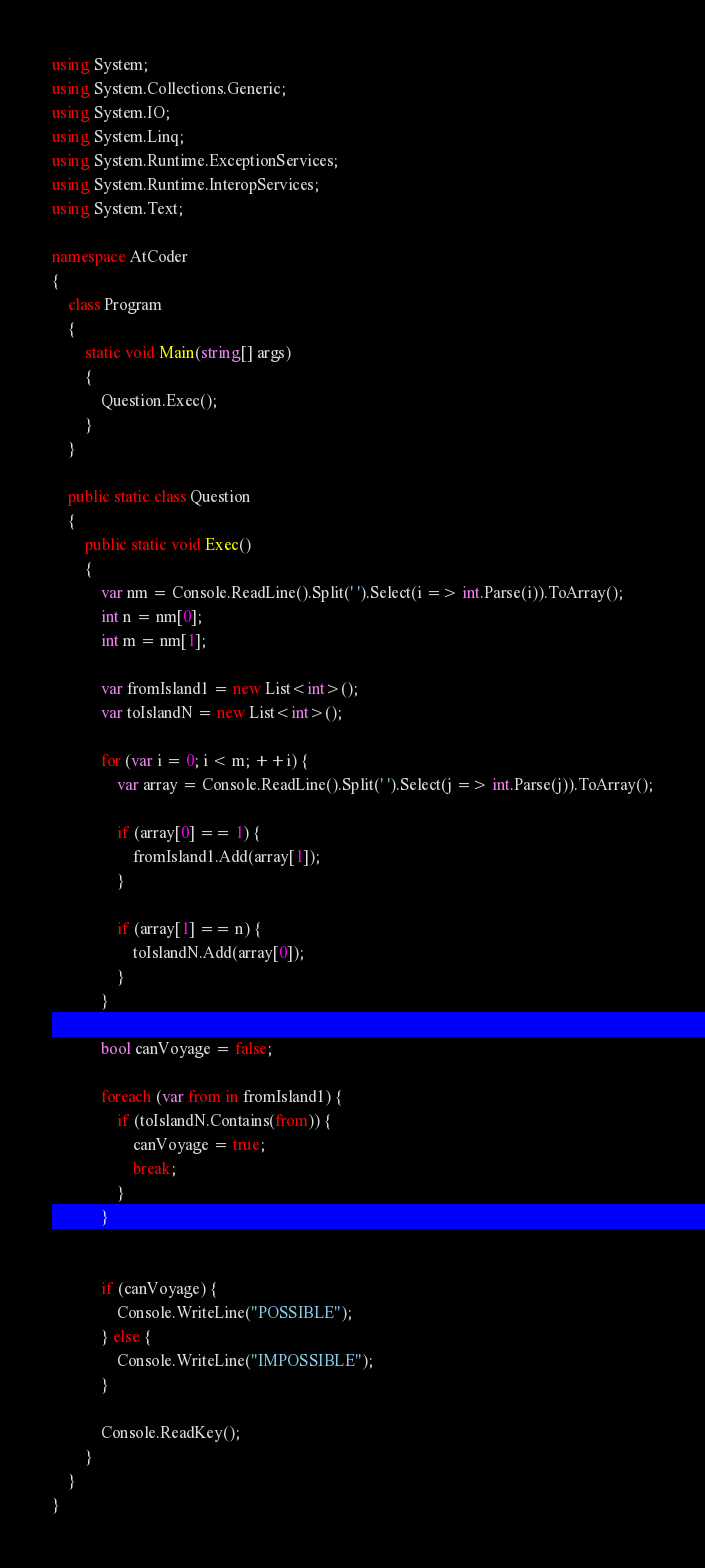Convert code to text. <code><loc_0><loc_0><loc_500><loc_500><_C#_>using System;
using System.Collections.Generic;
using System.IO;
using System.Linq;
using System.Runtime.ExceptionServices;
using System.Runtime.InteropServices;
using System.Text;

namespace AtCoder
{
	class Program
	{
		static void Main(string[] args)
		{
			Question.Exec();
		}
	}

	public static class Question
	{
		public static void Exec()
		{
			var nm = Console.ReadLine().Split(' ').Select(i => int.Parse(i)).ToArray();
			int n = nm[0];
			int m = nm[1];

			var fromIsland1 = new List<int>();
			var toIslandN = new List<int>();

			for (var i = 0; i < m; ++i) {
				var array = Console.ReadLine().Split(' ').Select(j => int.Parse(j)).ToArray();

				if (array[0] == 1) {
					fromIsland1.Add(array[1]);
				}

				if (array[1] == n) {
					toIslandN.Add(array[0]);
				}
			}

			bool canVoyage = false;

			foreach (var from in fromIsland1) {
				if (toIslandN.Contains(from)) {
					canVoyage = true;
					break;
				}
			}
			

			if (canVoyage) {
				Console.WriteLine("POSSIBLE");
			} else {
				Console.WriteLine("IMPOSSIBLE");
			}

			Console.ReadKey();
		}
	}
}</code> 